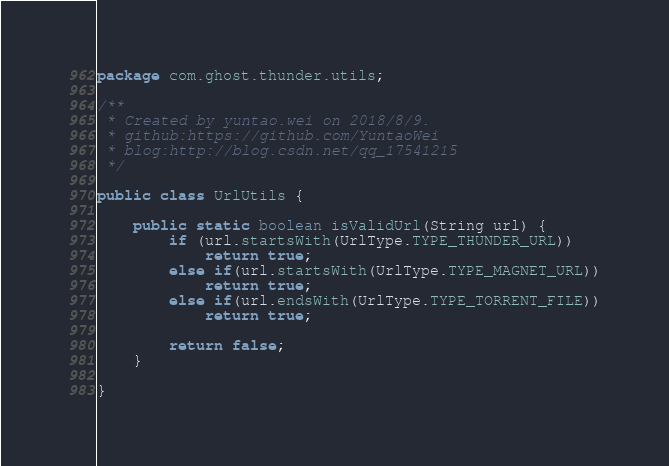<code> <loc_0><loc_0><loc_500><loc_500><_Java_>package com.ghost.thunder.utils;

/**
 * Created by yuntao.wei on 2018/8/9.
 * github:https://github.com/YuntaoWei
 * blog:http://blog.csdn.net/qq_17541215
 */

public class UrlUtils {

    public static boolean isValidUrl(String url) {
        if (url.startsWith(UrlType.TYPE_THUNDER_URL))
            return true;
        else if(url.startsWith(UrlType.TYPE_MAGNET_URL))
            return true;
        else if(url.endsWith(UrlType.TYPE_TORRENT_FILE))
            return true;

        return false;
    }

}
</code> 